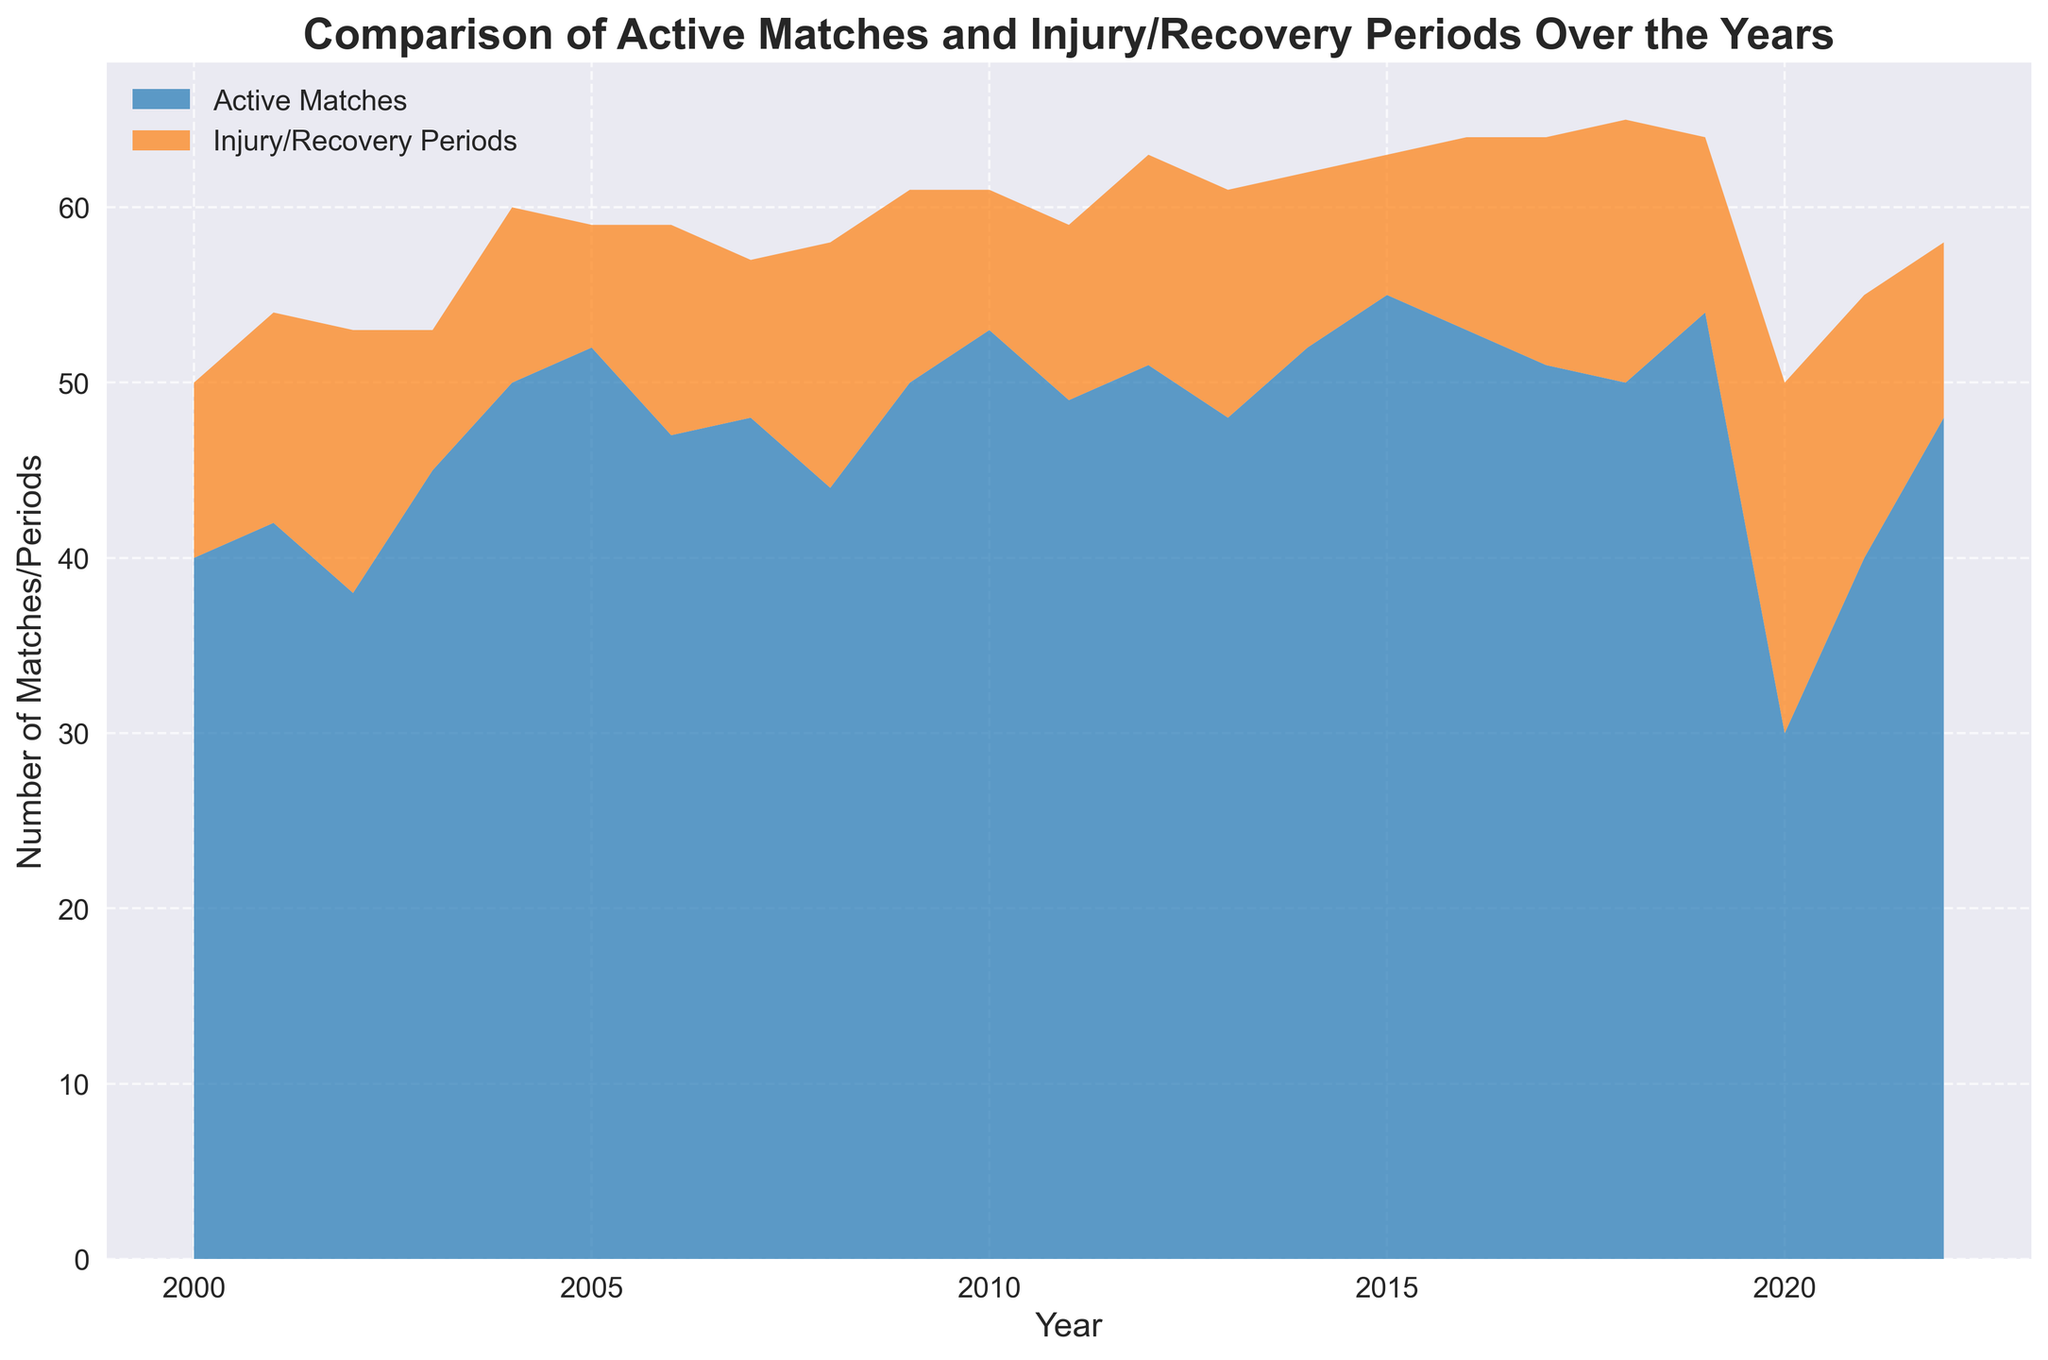What year has the highest number of active matches? To find the year with the highest number of active matches, look at the peak of the 'Active Matches' area on the chart. The highest point is at 2015.
Answer: 2015 What is the difference in the number of active matches between 2019 and 2020? Check the heights of the 'Active Matches' areas for 2019 and 2020. For 2019, it's 54, and for 2020, it's 30. The difference is 54 - 30 = 24.
Answer: 24 Which year shows the highest number of injury/recovery periods? To identify the year with the highest injury/recovery periods, locate the year with the tallest 'Injury/Recovery Periods' segment. The highest point is in 2020, with 20 periods.
Answer: 2020 How does the number of active matches in 2000 compare to 2022? Observe the chart for the years 2000 and 2022. In 2000, there are 40 active matches, and in 2022, there are 48. Thus, 2022 has 8 more active matches than 2000.
Answer: 8 more Which year had more time spent in recovery/injury periods compared to active matches? By comparing the heights of both areas on the chart, look for times when 'Injury/Recovery Periods' is taller than 'Active Matches'. This occurred in 2020, with 20 periods in recovery compared to 30 active matches.
Answer: 2020 What is the average number of active matches over the years 2018 to 2022? Add the active matches from 2018 (50), 2019 (54), 2020 (30), 2021 (40), and 2022 (48): 50 + 54 + 30 + 40 + 48 = 222. Then, divide by 5 (number of years): 222 / 5 = 44.4.
Answer: 44.4 Which year had the smallest gap between active matches and injury/recovery periods? Compare the differences between the heights of the two areas each year to find the smallest. In 2000, the difference is 40 - 10 = 30. In 2020, it's 30 - 20 = 10. The smallest gap is in 2020.
Answer: 2020 What is the trend in the number of active matches from 2000 to 2005? Look at the 'Active Matches' section from 2000 to 2005. The trend is increasing: 40 (2000), 42 (2001), 38 (2002), 45 (2003), 50 (2004), and 52 (2005). Overall, active matches increase.
Answer: increasing By how much did the injury/recovery periods increase from 2018 to 2020? The 'Injury/Recovery Periods' in 2018 is 15, and in 2020 it is 20. The increase is 20 - 15 = 5.
Answer: 5 Which color represents the active matches on the chart? Observe the colors in the legend of the chart. 'Active Matches' is associated with blue.
Answer: blue 